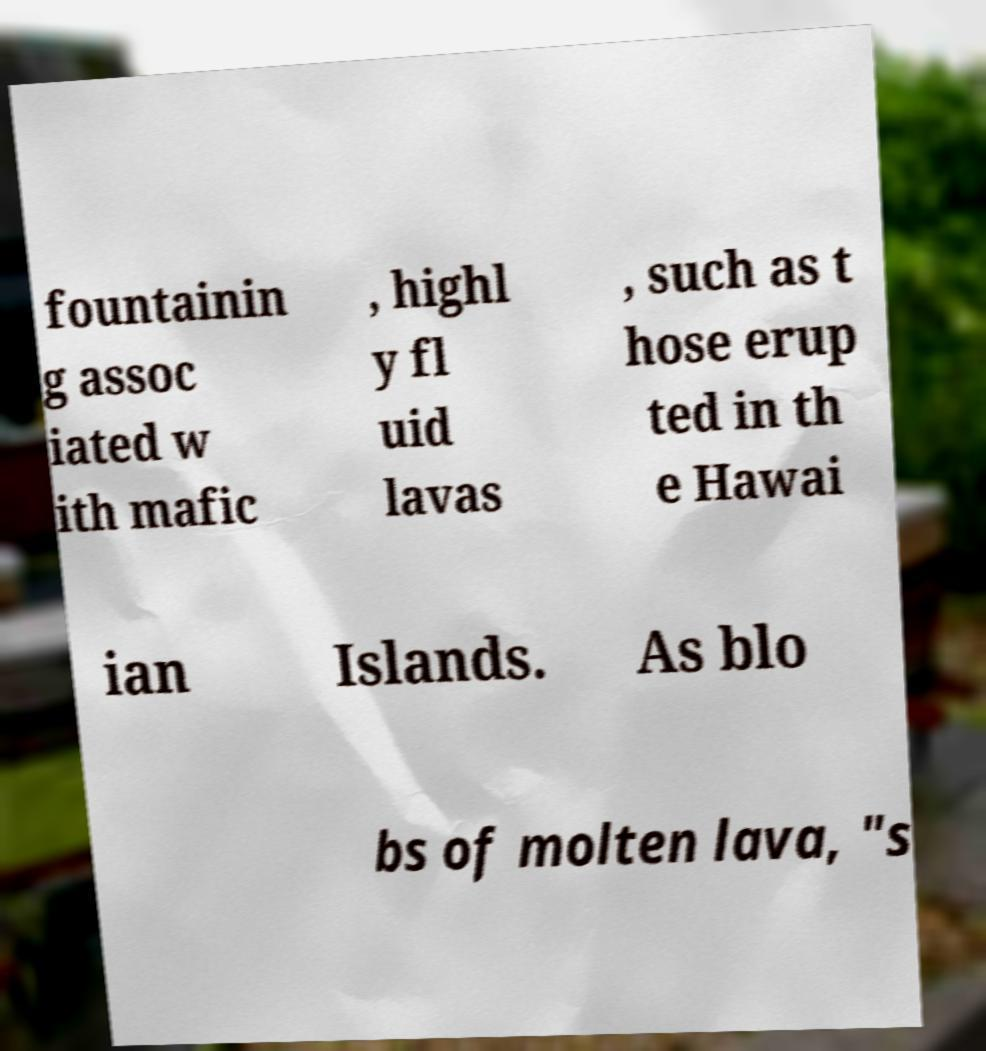Please read and relay the text visible in this image. What does it say? fountainin g assoc iated w ith mafic , highl y fl uid lavas , such as t hose erup ted in th e Hawai ian Islands. As blo bs of molten lava, "s 